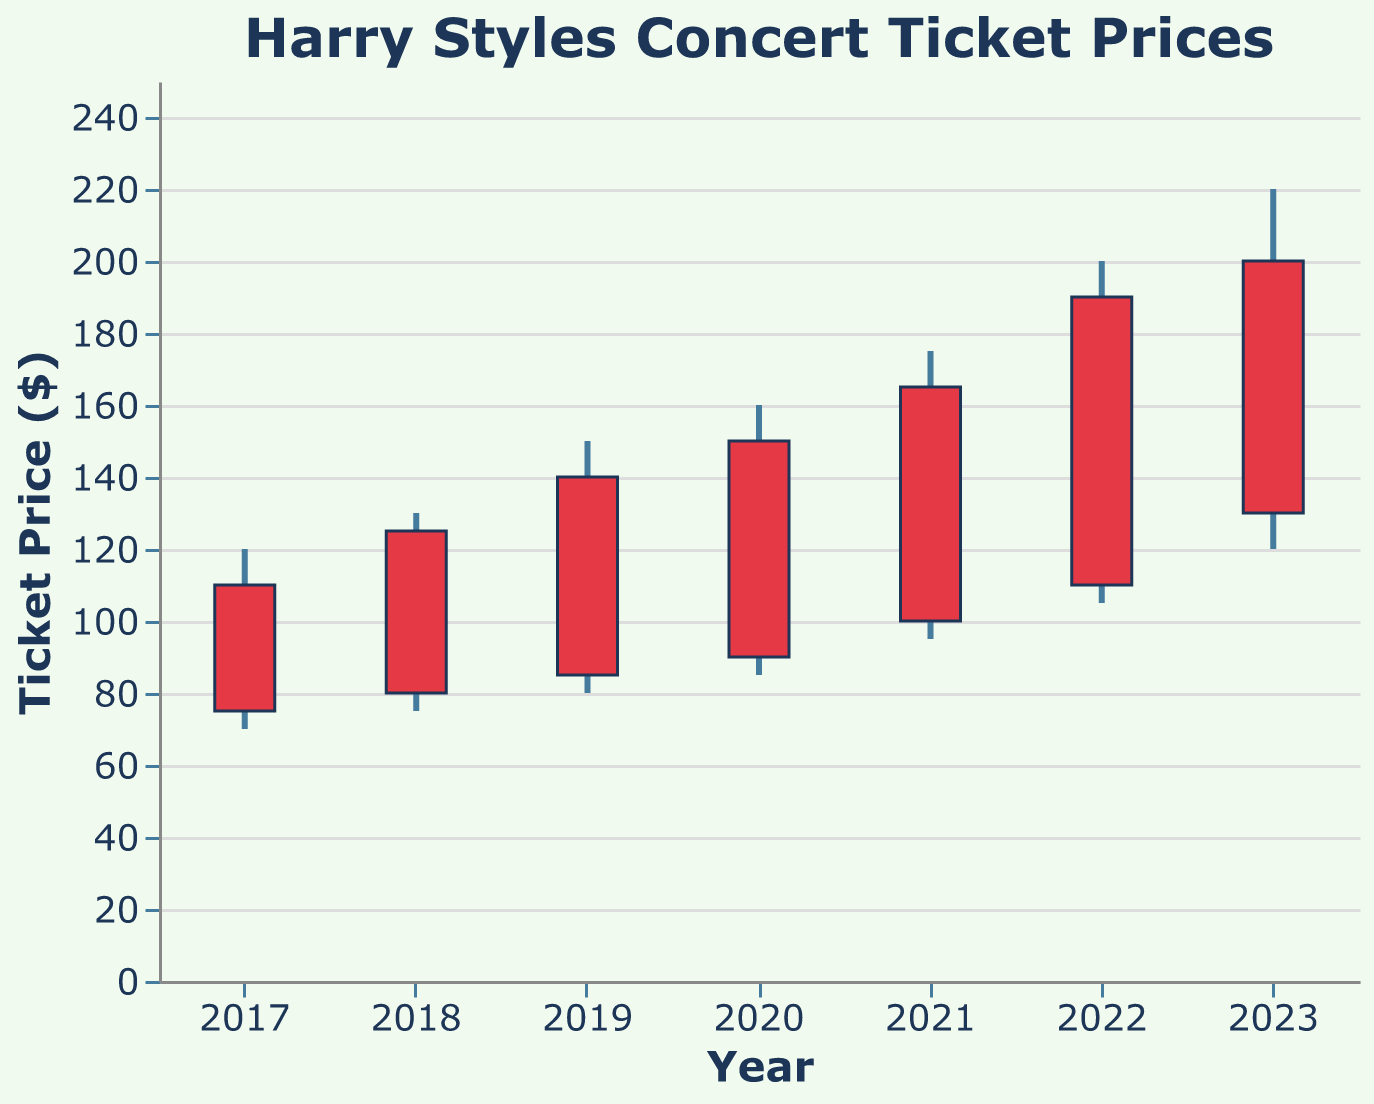What's the highest ticket price recorded during 2020? The highest ticket price can be found by looking at the "High" value for the year 2020 in the plot, which is $160.
Answer: $160 Which year had the lowest opening ticket price? The opening ticket prices can be found along the bottom of the candlestick bars. The lowest opening ticket price is in the year 2017 with $75.
Answer: 2017 How much did the closing ticket price increase from 2017 to 2023? Find the closing price for 2017 ($110) and 2023 ($200) and calculate the increase: $200 - $110 = $90.
Answer: $90 In which year did the ticket price have the largest range from lowest to highest? To find this, calculate the range (High - Low) for each year and compare them. The largest range is in 2023: $220 - $120 = $100.
Answer: 2023 What is the average closing ticket price over all the years? Sum up the closing prices for all years ($110, $125, $140, $150, $165, $190, $200) which equals $1080. There are 7 years, so $1080 / 7 = $154.29.
Answer: $154.29 Did any year's closing price equal the next year's opening price? Compare the closing price of each year to the following year's opening price. None of the years have closing prices equal to the next year's opening prices.
Answer: No Between which two consecutive years was the largest increase in closing ticket prices? Calculate the difference in closing prices between each consecutive year and compare them. The largest increase is from 2021 ($165) to 2022 ($190), which is $25.
Answer: 2021 to 2022 How many years had an upward trend in ticket prices (i.e., closing price higher than opening price)? For each year, check if the closing price is higher than the opening price. This happens in every year: 2017, 2018, 2019, 2020, 2021, 2022, and 2023.
Answer: 7 years Which year had the smallest difference between opening and closing prices? Calculate the difference between opening and closing prices for each year and compare. The smallest difference is in 2020: $150 - $90 = $60.
Answer: 2020 What was the closing ticket price in 2022? Find the closing price for the year 2022 in the plot, which is $190.
Answer: $190 